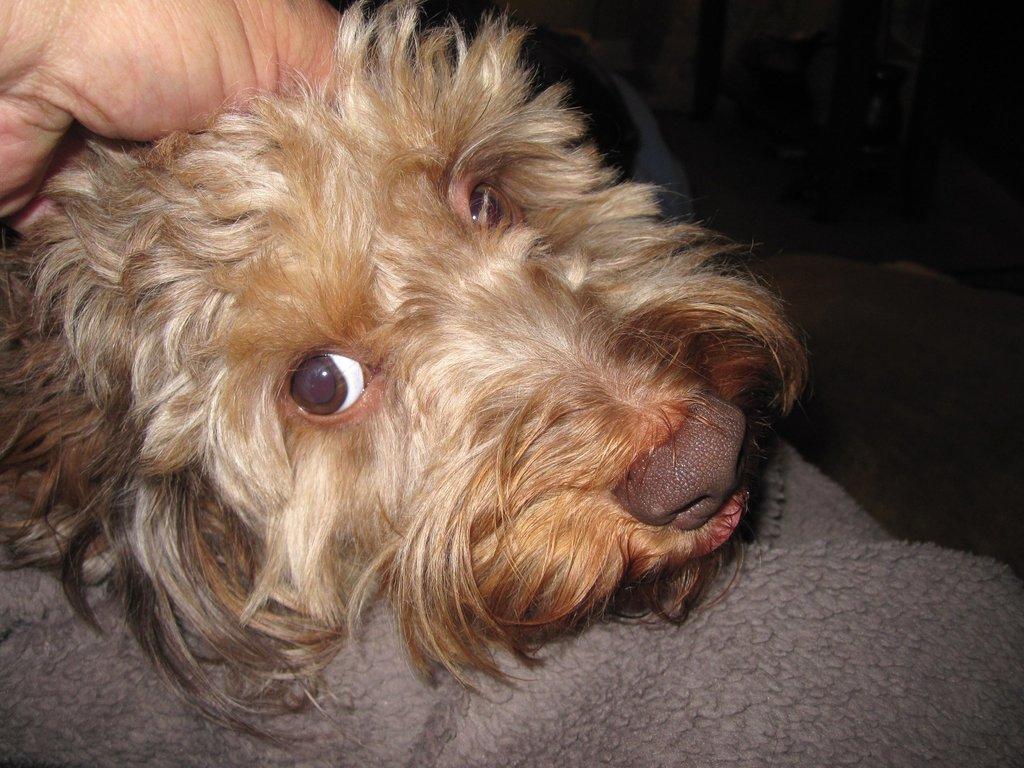How would you summarize this image in a sentence or two? In this image we can see a brown color dog. Top left of the image one hand is there. 